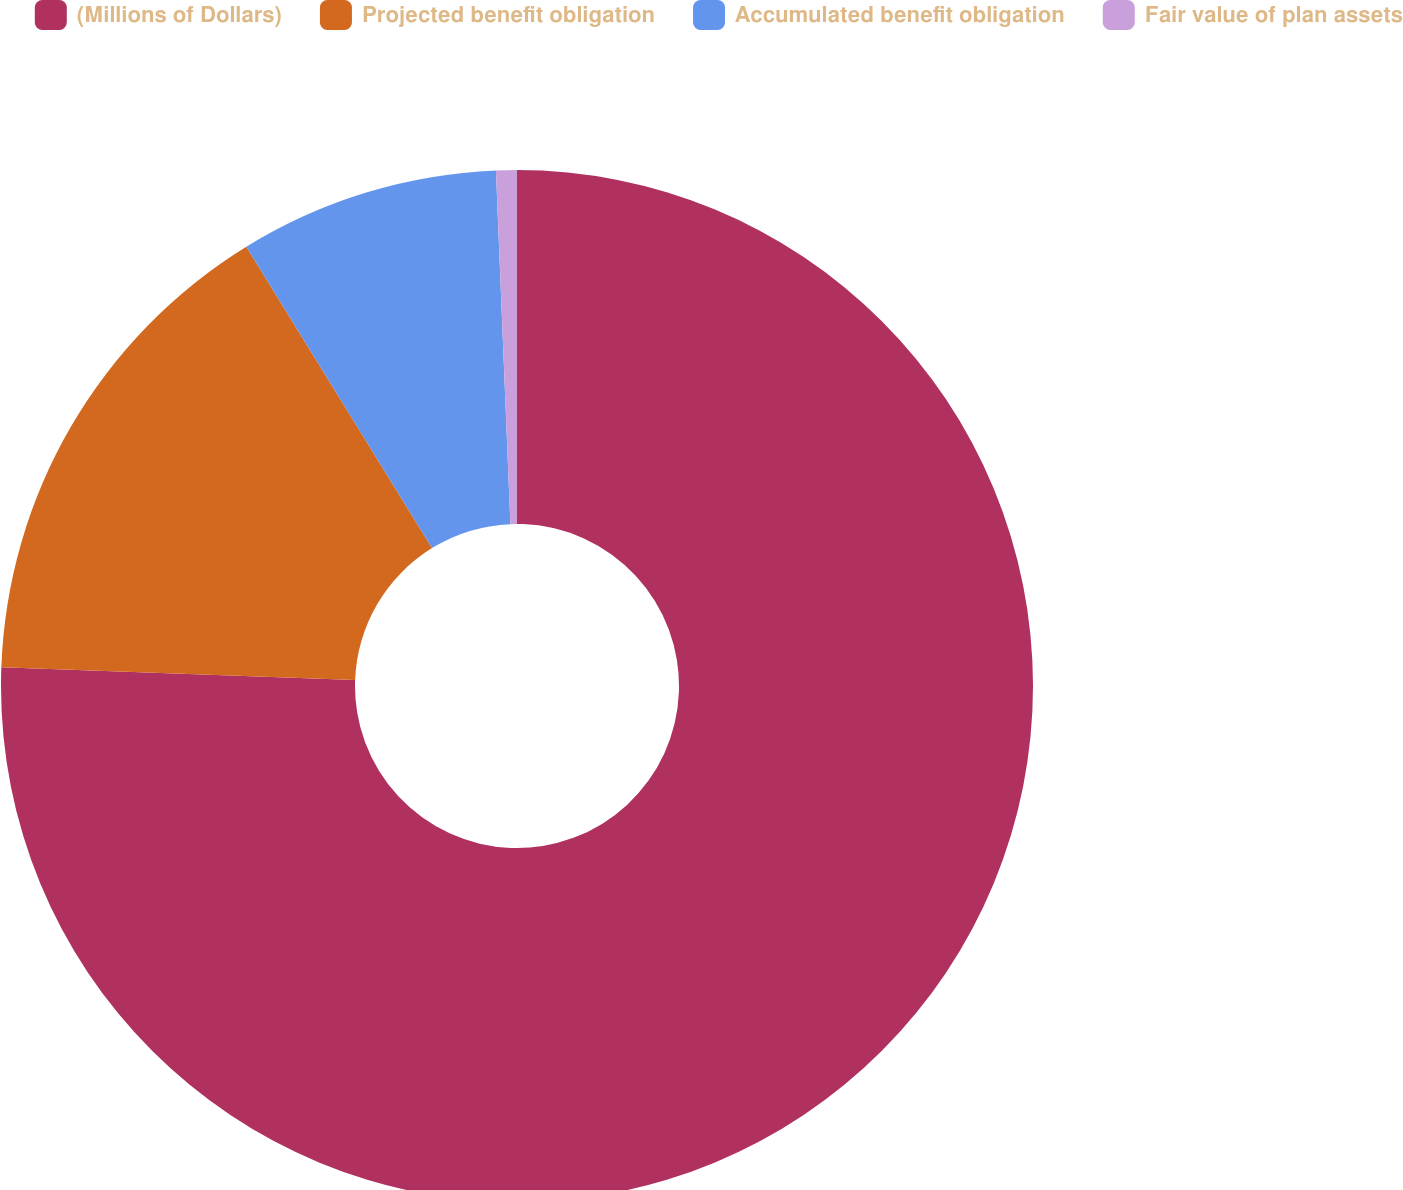Convert chart to OTSL. <chart><loc_0><loc_0><loc_500><loc_500><pie_chart><fcel>(Millions of Dollars)<fcel>Projected benefit obligation<fcel>Accumulated benefit obligation<fcel>Fair value of plan assets<nl><fcel>75.58%<fcel>15.63%<fcel>8.14%<fcel>0.65%<nl></chart> 